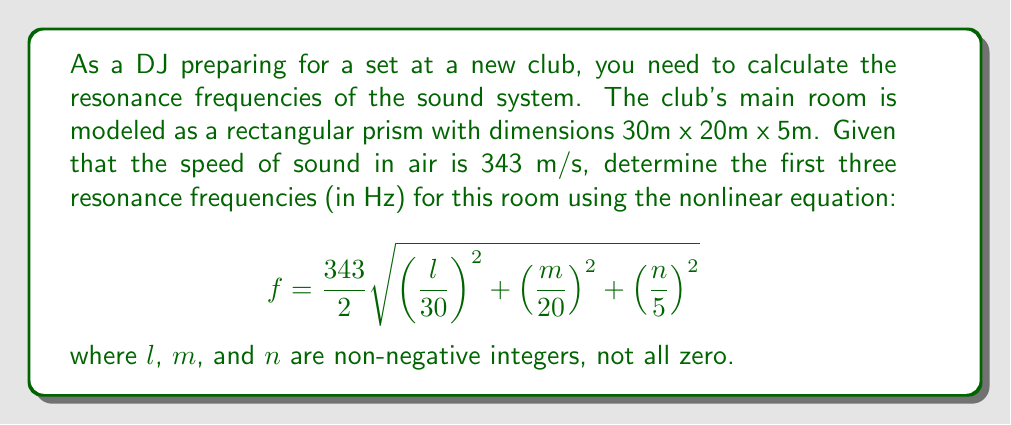Teach me how to tackle this problem. To solve this problem, we need to follow these steps:

1) The given equation is:
   $$f = \frac{343}{2} \sqrt{\left(\frac{l}{30}\right)^2 + \left(\frac{m}{20}\right)^2 + \left(\frac{n}{5}\right)^2}$$

2) We need to find the first three lowest non-zero frequencies. This means we need to consider different combinations of $l$, $m$, and $n$, starting with the smallest possible values.

3) The possible combinations for the first three frequencies are:
   (1,0,0), (0,1,0), and (0,0,1)

4) Let's calculate each:

   For (1,0,0):
   $$f_1 = \frac{343}{2} \sqrt{\left(\frac{1}{30}\right)^2 + 0^2 + 0^2} = \frac{343}{2} \cdot \frac{1}{30} = 5.72 \text{ Hz}$$

   For (0,1,0):
   $$f_2 = \frac{343}{2} \sqrt{0^2 + \left(\frac{1}{20}\right)^2 + 0^2} = \frac{343}{2} \cdot \frac{1}{20} = 8.575 \text{ Hz}$$

   For (0,0,1):
   $$f_3 = \frac{343}{2} \sqrt{0^2 + 0^2 + \left(\frac{1}{5}\right)^2} = \frac{343}{2} \cdot \frac{1}{5} = 34.3 \text{ Hz}$$

5) Rounding to two decimal places, we get:
   $f_1 = 5.72 \text{ Hz}$, $f_2 = 8.58 \text{ Hz}$, $f_3 = 34.30 \text{ Hz}$
Answer: 5.72 Hz, 8.58 Hz, 34.30 Hz 